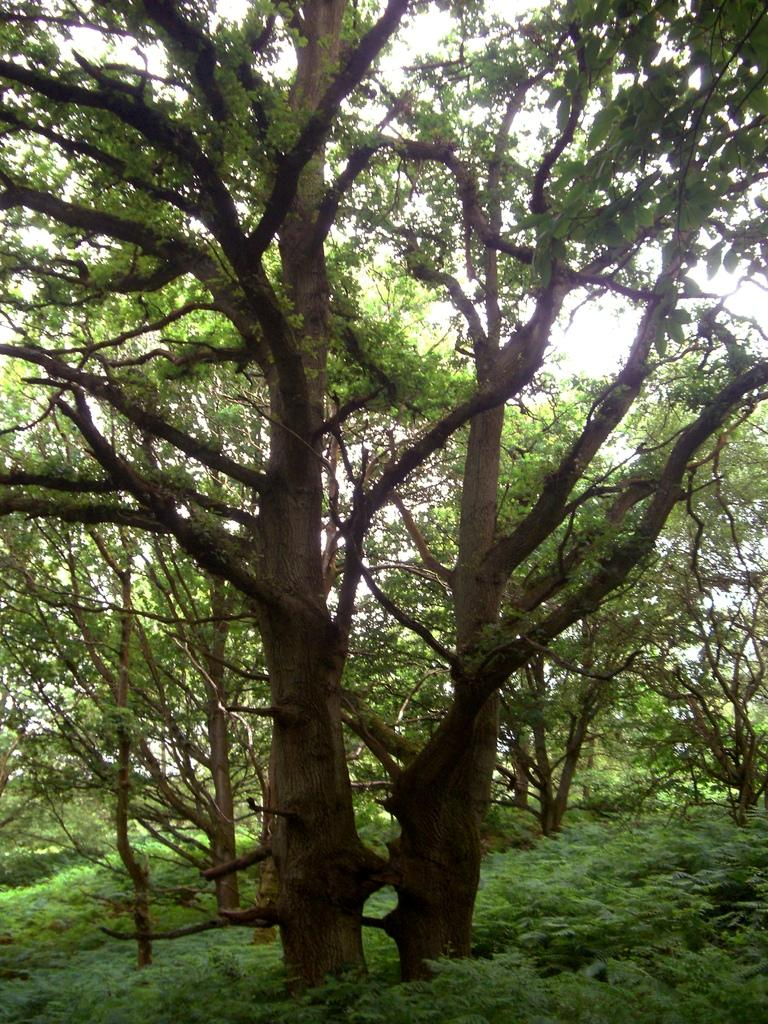What type of vegetation can be seen in the image? There are trees in the image. What is the color of the trees in the image? The trees are green in color. What part of the natural environment is visible in the image? The sky is visible in the background of the image. What is the color of the sky in the image? The sky is white in color. How does the page in the image compare to the coil? There is no page or coil present in the image; it only features trees and a white sky. 